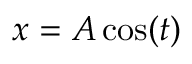<formula> <loc_0><loc_0><loc_500><loc_500>x = A \cos ( t )</formula> 